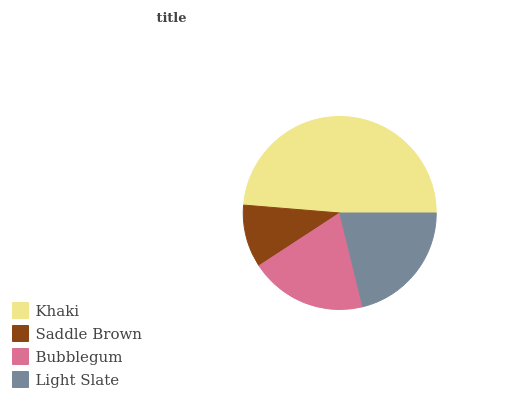Is Saddle Brown the minimum?
Answer yes or no. Yes. Is Khaki the maximum?
Answer yes or no. Yes. Is Bubblegum the minimum?
Answer yes or no. No. Is Bubblegum the maximum?
Answer yes or no. No. Is Bubblegum greater than Saddle Brown?
Answer yes or no. Yes. Is Saddle Brown less than Bubblegum?
Answer yes or no. Yes. Is Saddle Brown greater than Bubblegum?
Answer yes or no. No. Is Bubblegum less than Saddle Brown?
Answer yes or no. No. Is Light Slate the high median?
Answer yes or no. Yes. Is Bubblegum the low median?
Answer yes or no. Yes. Is Bubblegum the high median?
Answer yes or no. No. Is Saddle Brown the low median?
Answer yes or no. No. 